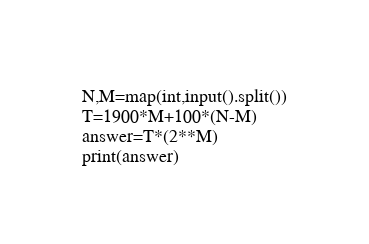Convert code to text. <code><loc_0><loc_0><loc_500><loc_500><_Python_>N,M=map(int,input().split())
T=1900*M+100*(N-M)
answer=T*(2**M)
print(answer)</code> 